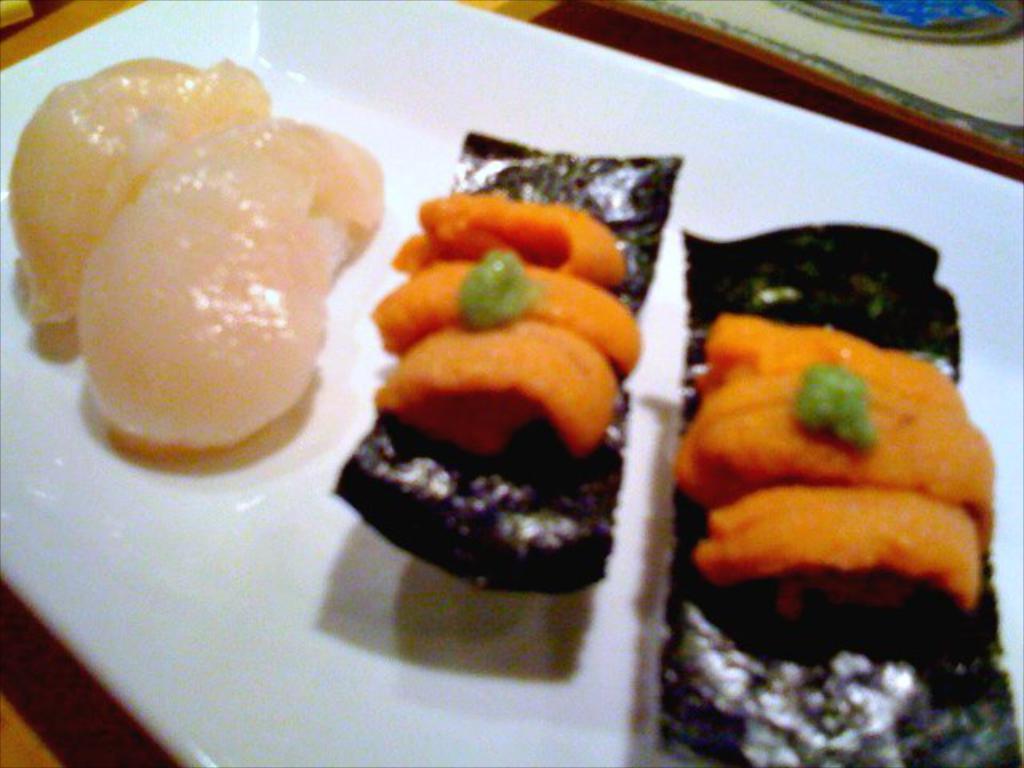Could you give a brief overview of what you see in this image? In this picture we can see some food items on the white plate and the plate is on a wooden object. On the right side of the plate it looks like a table mat. 